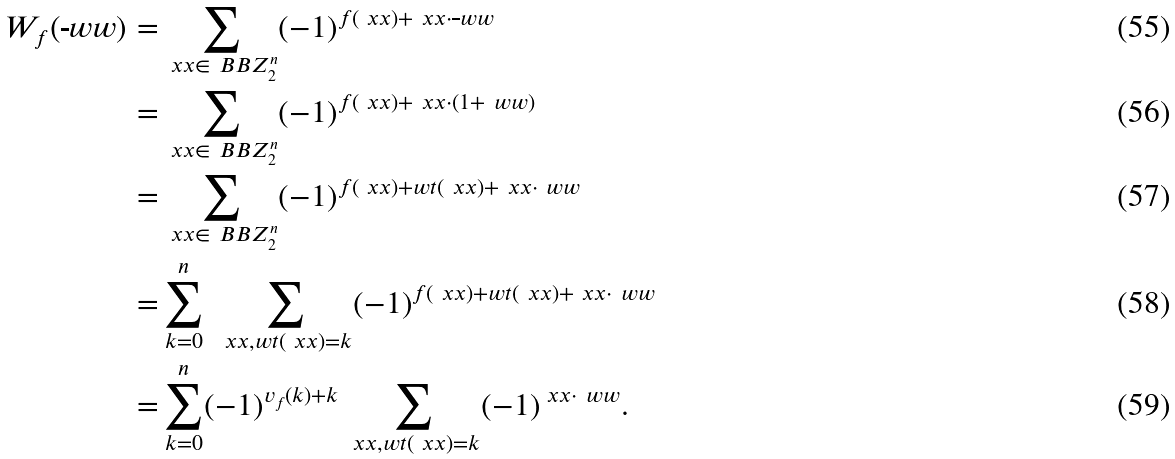<formula> <loc_0><loc_0><loc_500><loc_500>W _ { f } ( \overline { \ } w w ) = & \sum _ { \ x x \in \ B B Z _ { 2 } ^ { n } } ( - 1 ) ^ { f ( \ x x ) + \ x x \cdot \overline { \ } w w } \\ = & \sum _ { \ x x \in \ B B Z _ { 2 } ^ { n } } ( - 1 ) ^ { f ( \ x x ) + \ x x \cdot ( { 1 } + \ w w ) } \\ = & \sum _ { \ x x \in \ B B Z _ { 2 } ^ { n } } ( - 1 ) ^ { f ( \ x x ) + w t ( \ x x ) + \ x x \cdot \ w w } \\ = & \sum _ { k = 0 } ^ { n } \ \sum _ { \ x x , w t ( \ x x ) = k } ( - 1 ) ^ { f ( \ x x ) + w t ( \ x x ) + \ x x \cdot \ w w } \\ = & \sum _ { k = 0 } ^ { n } ( - 1 ) ^ { v _ { f } ( k ) + k } \sum _ { \ x x , w t ( \ x x ) = k } ( - 1 ) ^ { \ x x \cdot \ w w } .</formula> 